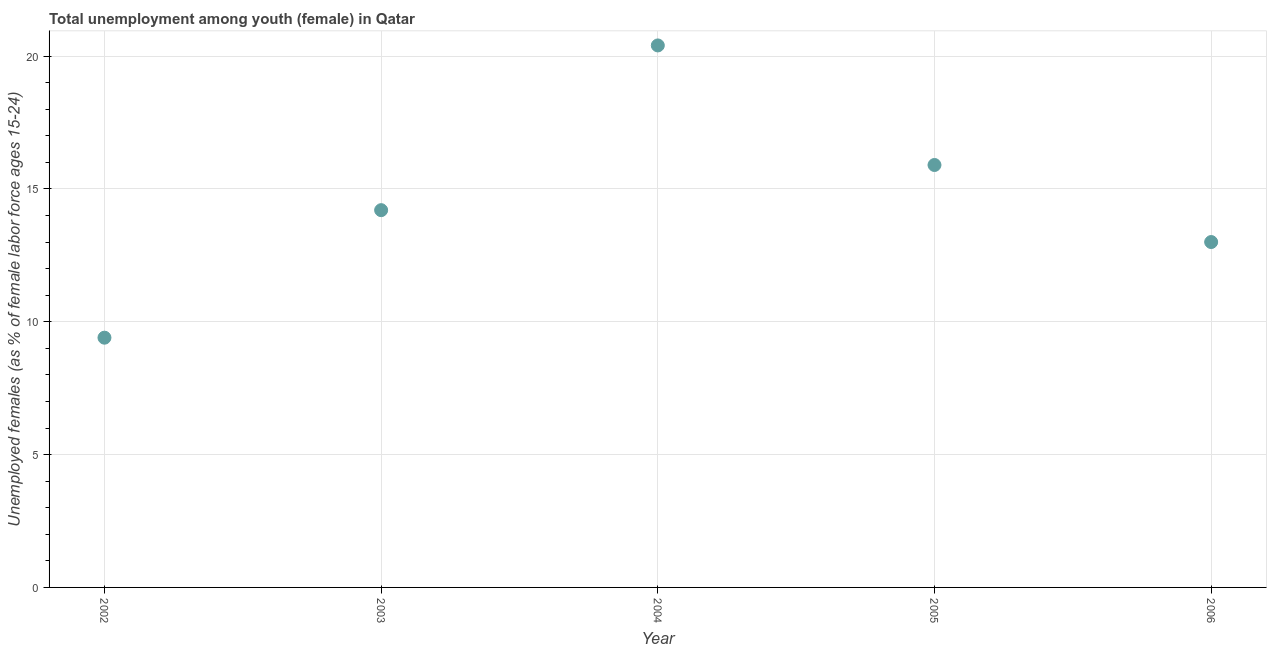What is the unemployed female youth population in 2004?
Keep it short and to the point. 20.4. Across all years, what is the maximum unemployed female youth population?
Your response must be concise. 20.4. Across all years, what is the minimum unemployed female youth population?
Your response must be concise. 9.4. In which year was the unemployed female youth population maximum?
Offer a terse response. 2004. What is the sum of the unemployed female youth population?
Keep it short and to the point. 72.9. What is the difference between the unemployed female youth population in 2002 and 2005?
Offer a terse response. -6.5. What is the average unemployed female youth population per year?
Provide a succinct answer. 14.58. What is the median unemployed female youth population?
Your answer should be compact. 14.2. In how many years, is the unemployed female youth population greater than 11 %?
Ensure brevity in your answer.  4. What is the ratio of the unemployed female youth population in 2002 to that in 2004?
Offer a very short reply. 0.46. Is the unemployed female youth population in 2002 less than that in 2005?
Keep it short and to the point. Yes. What is the difference between the highest and the second highest unemployed female youth population?
Give a very brief answer. 4.5. Is the sum of the unemployed female youth population in 2002 and 2006 greater than the maximum unemployed female youth population across all years?
Make the answer very short. Yes. What is the difference between the highest and the lowest unemployed female youth population?
Keep it short and to the point. 11. In how many years, is the unemployed female youth population greater than the average unemployed female youth population taken over all years?
Make the answer very short. 2. Does the unemployed female youth population monotonically increase over the years?
Give a very brief answer. No. How many dotlines are there?
Keep it short and to the point. 1. How many years are there in the graph?
Provide a succinct answer. 5. What is the difference between two consecutive major ticks on the Y-axis?
Your answer should be very brief. 5. Are the values on the major ticks of Y-axis written in scientific E-notation?
Your response must be concise. No. What is the title of the graph?
Your answer should be very brief. Total unemployment among youth (female) in Qatar. What is the label or title of the Y-axis?
Give a very brief answer. Unemployed females (as % of female labor force ages 15-24). What is the Unemployed females (as % of female labor force ages 15-24) in 2002?
Keep it short and to the point. 9.4. What is the Unemployed females (as % of female labor force ages 15-24) in 2003?
Give a very brief answer. 14.2. What is the Unemployed females (as % of female labor force ages 15-24) in 2004?
Provide a succinct answer. 20.4. What is the Unemployed females (as % of female labor force ages 15-24) in 2005?
Give a very brief answer. 15.9. What is the Unemployed females (as % of female labor force ages 15-24) in 2006?
Offer a terse response. 13. What is the difference between the Unemployed females (as % of female labor force ages 15-24) in 2002 and 2004?
Your response must be concise. -11. What is the difference between the Unemployed females (as % of female labor force ages 15-24) in 2003 and 2005?
Keep it short and to the point. -1.7. What is the difference between the Unemployed females (as % of female labor force ages 15-24) in 2003 and 2006?
Give a very brief answer. 1.2. What is the difference between the Unemployed females (as % of female labor force ages 15-24) in 2005 and 2006?
Your answer should be compact. 2.9. What is the ratio of the Unemployed females (as % of female labor force ages 15-24) in 2002 to that in 2003?
Provide a short and direct response. 0.66. What is the ratio of the Unemployed females (as % of female labor force ages 15-24) in 2002 to that in 2004?
Provide a succinct answer. 0.46. What is the ratio of the Unemployed females (as % of female labor force ages 15-24) in 2002 to that in 2005?
Your response must be concise. 0.59. What is the ratio of the Unemployed females (as % of female labor force ages 15-24) in 2002 to that in 2006?
Offer a terse response. 0.72. What is the ratio of the Unemployed females (as % of female labor force ages 15-24) in 2003 to that in 2004?
Your answer should be very brief. 0.7. What is the ratio of the Unemployed females (as % of female labor force ages 15-24) in 2003 to that in 2005?
Provide a succinct answer. 0.89. What is the ratio of the Unemployed females (as % of female labor force ages 15-24) in 2003 to that in 2006?
Ensure brevity in your answer.  1.09. What is the ratio of the Unemployed females (as % of female labor force ages 15-24) in 2004 to that in 2005?
Your answer should be compact. 1.28. What is the ratio of the Unemployed females (as % of female labor force ages 15-24) in 2004 to that in 2006?
Keep it short and to the point. 1.57. What is the ratio of the Unemployed females (as % of female labor force ages 15-24) in 2005 to that in 2006?
Keep it short and to the point. 1.22. 